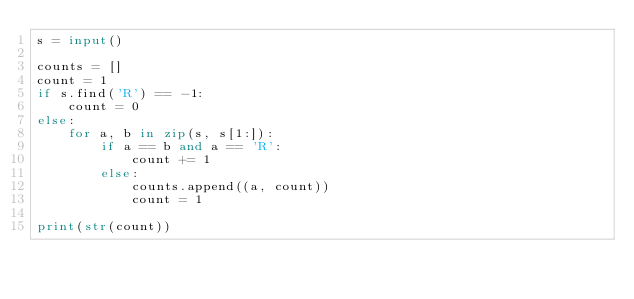<code> <loc_0><loc_0><loc_500><loc_500><_Python_>s = input()

counts = []
count = 1
if s.find('R') == -1:
    count = 0
else:
    for a, b in zip(s, s[1:]):
        if a == b and a == 'R':
            count += 1
        else:
            counts.append((a, count))
            count = 1

print(str(count))
</code> 